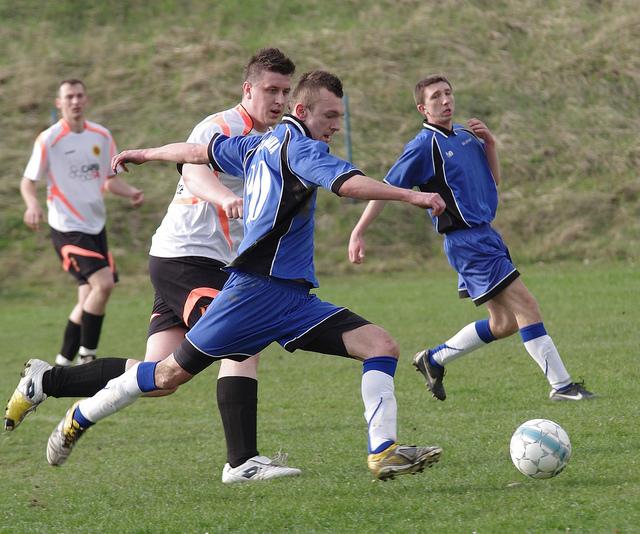Are both players girls?
Short answer required. No. What game is this?
Concise answer only. Soccer. Are these girls or boys?
Give a very brief answer. Boys. What color is the uniform?
Keep it brief. Blue. What is the man trying to kick?
Be succinct. Soccer ball. 